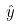Convert formula to latex. <formula><loc_0><loc_0><loc_500><loc_500>\hat { y }</formula> 